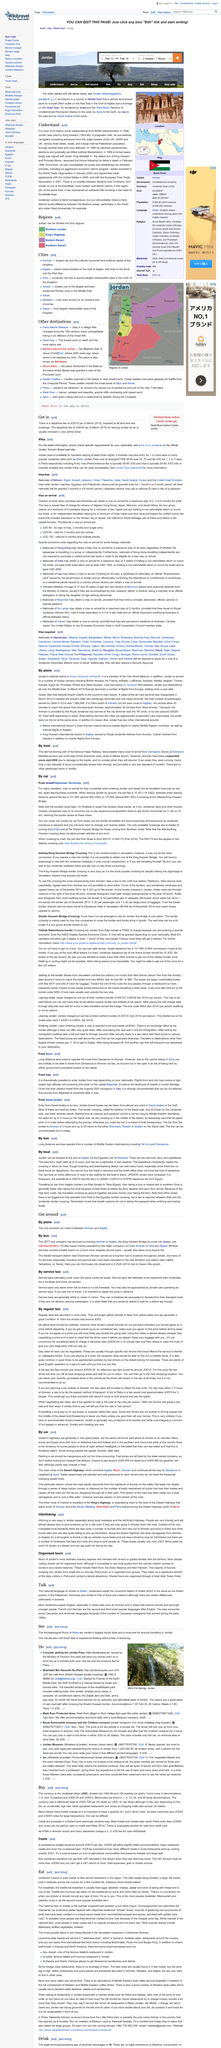List a handful of essential elements in this visual. A Jordan Pass is eligible for travelers who stay at least three nights in Jordan. A Jordan pass, which includes visa plus entry for 1 or more days to numerous popular Jordanian sites, is included in the package. For the most up-to-date information on entry requirements for Jordan, please refer to the official Jordan Tourism Board website. 